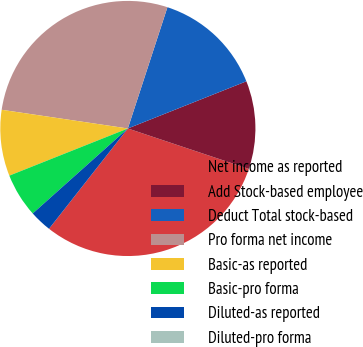Convert chart. <chart><loc_0><loc_0><loc_500><loc_500><pie_chart><fcel>Net income as reported<fcel>Add Stock-based employee<fcel>Deduct Total stock-based<fcel>Pro forma net income<fcel>Basic-as reported<fcel>Basic-pro forma<fcel>Diluted-as reported<fcel>Diluted-pro forma<nl><fcel>30.47%<fcel>11.16%<fcel>13.95%<fcel>27.68%<fcel>8.37%<fcel>5.58%<fcel>2.79%<fcel>0.0%<nl></chart> 